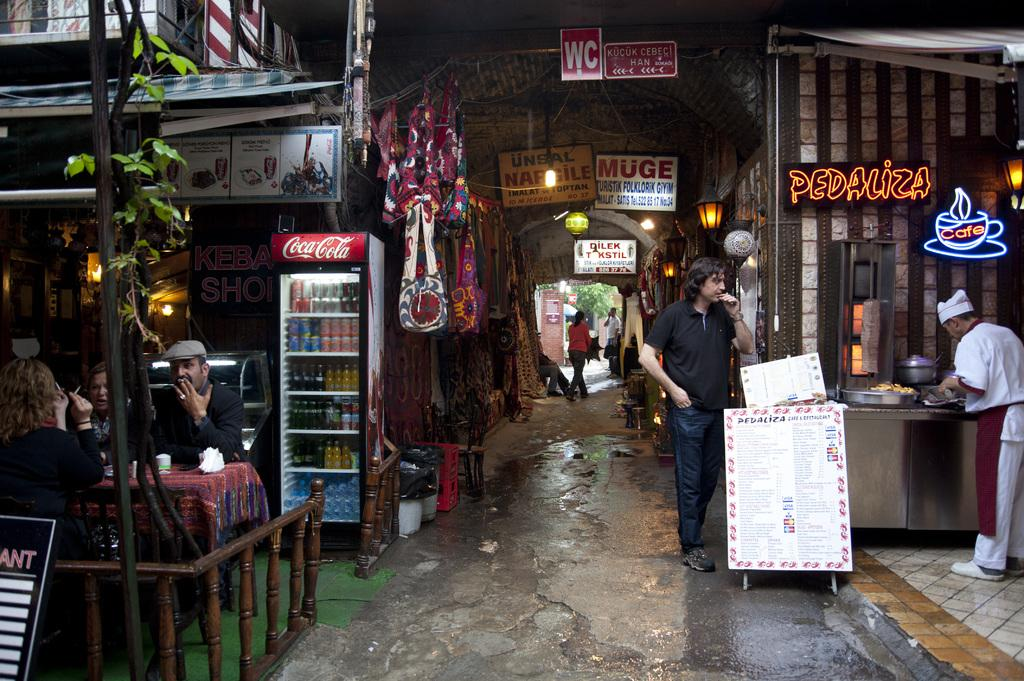What can be seen in the foreground of the image? In the foreground of the image, there are stalls, people, a refrigerator, and posters. How many people are visible in the foreground of the image? There are people in the foreground of the image, but the exact number is not specified. What is located in the background of the image? In the background of the image, there is a building and a tree. Are there any people in the background of the image? Yes, there are people in the background of the image. What type of fiction is being sold at the market in the image? There is no mention of a market or fiction being sold in the image. What is the copper content of the refrigerator in the image? The image does not provide information about the composition of the refrigerator, including its copper content. 